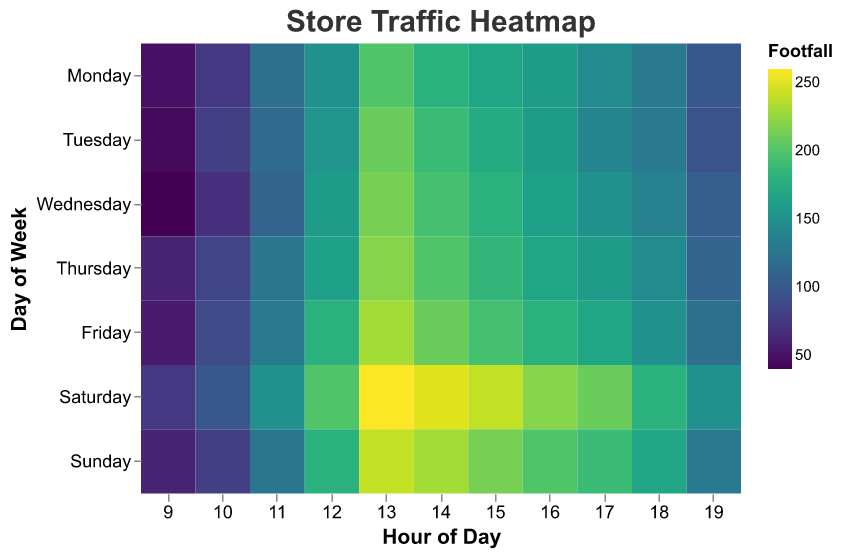What is the title of the heatmap? The title can usually be found at the top of the figure. In this case, the title is "Store Traffic Heatmap".
Answer: Store Traffic Heatmap Which day has the highest footfall at 13:00? To find the highest footfall at 13:00, locate the column for 13:00 and compare the footfall values across all days. The highest value in that column is 260 on Saturday.
Answer: Saturday During which hours does Monday experience the highest footfall? To find this, look at Monday's row and identify the hour with the highest footfall value. For Monday, the highest footfall is 200 at 13:00.
Answer: 13:00 Compare the footfall at 14:00 on Wednesday and Friday; which is higher? Locate the 14:00 column and compare the footfall values for Wednesday and Friday. The footfall on Wednesday is 195, while on Friday, it is 210. Friday has the higher footfall.
Answer: Friday Which day has the lowest overall footfall at 9:00? To determine the lowest footfall at 9:00, look at the 9:00 column and identify the smallest value, which is 40 on Wednesday.
Answer: Wednesday On which day is the footfall at 12:00 the same as 16:00? Compare the footfall values for each day at 12:00 and 16:00. For Thursday, both values are 165.
Answer: Thursday Which hour sees the maximum footfall across the entire week? Check all hourly columns and identify the maximum footfall value. The highest is 260 at 13:00 on Saturday.
Answer: 13:00 Calculate the average footfall at 18:00 for the entire week. Add footfall values for all days at 18:00: 130 (Mon) + 130 (Tue) + 135 (Wed) + 145 (Thu) + 150 (Fri) + 180 (Sat) + 170 (Sun) = 1040. Divide by 7 (number of days) to get 1040/7 ≈ 148.6.
Answer: 148.6 Compare the footfall at 15:00 between Monday and Tuesday and find out how much higher it is on the day with more footfall. Monday's footfall at 15:00 is 170, and Tuesday's is 175. The difference is 175 - 170 = 5.
Answer: 5 What is the trend of footfall from 12:00 to 14:00 on Sunday? Look at the values from 12:00 to 14:00 on Sunday: 180 (12:00), 240 (13:00), 230 (14:00). The footfall increases at 13:00 and then slightly decreases at 14:00.
Answer: Increases then decreases 